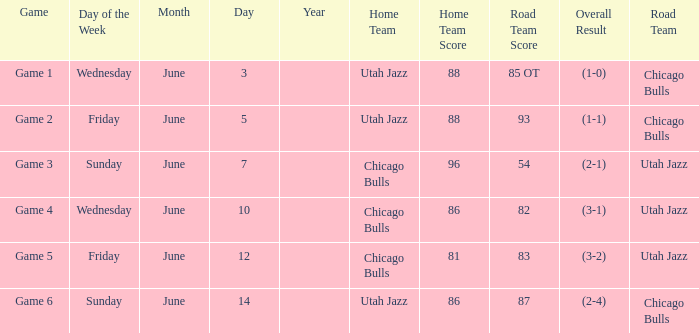Result of 86-87 (2-4) involves what home team? Utah Jazz. 